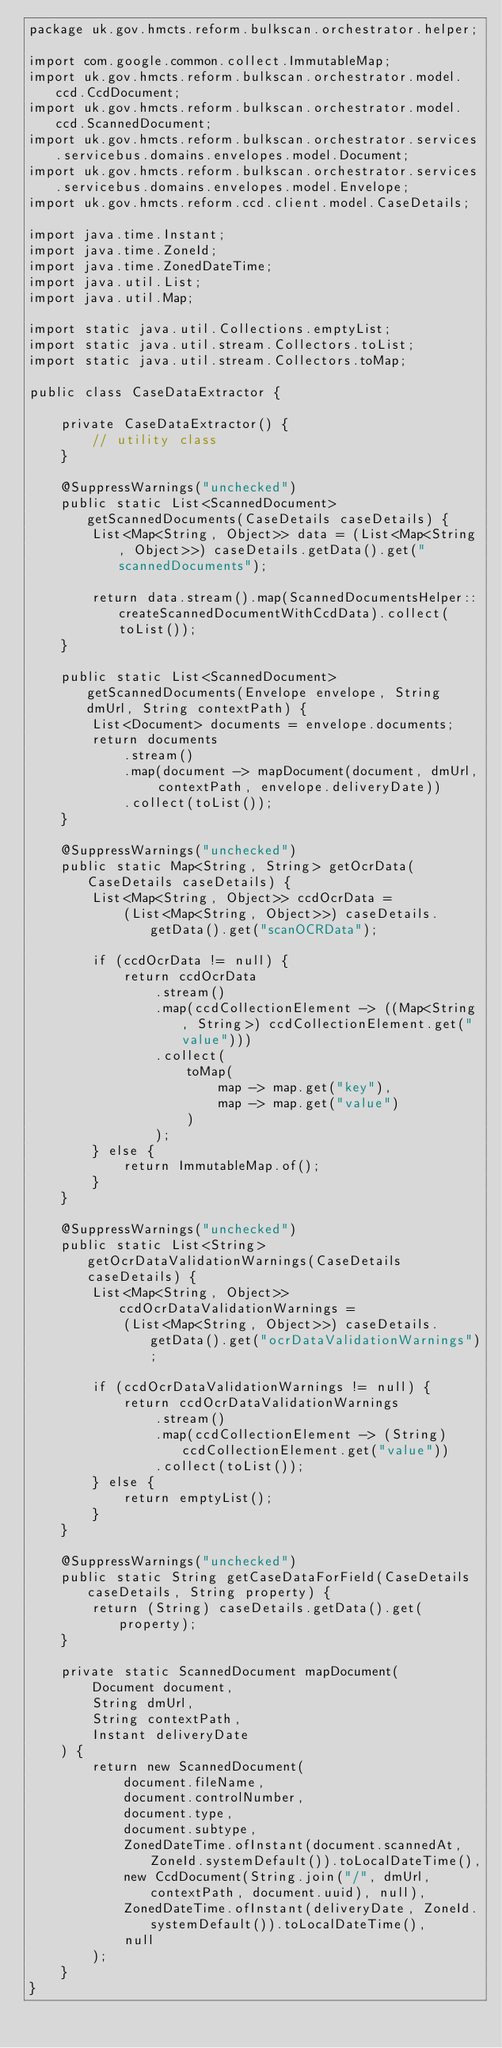<code> <loc_0><loc_0><loc_500><loc_500><_Java_>package uk.gov.hmcts.reform.bulkscan.orchestrator.helper;

import com.google.common.collect.ImmutableMap;
import uk.gov.hmcts.reform.bulkscan.orchestrator.model.ccd.CcdDocument;
import uk.gov.hmcts.reform.bulkscan.orchestrator.model.ccd.ScannedDocument;
import uk.gov.hmcts.reform.bulkscan.orchestrator.services.servicebus.domains.envelopes.model.Document;
import uk.gov.hmcts.reform.bulkscan.orchestrator.services.servicebus.domains.envelopes.model.Envelope;
import uk.gov.hmcts.reform.ccd.client.model.CaseDetails;

import java.time.Instant;
import java.time.ZoneId;
import java.time.ZonedDateTime;
import java.util.List;
import java.util.Map;

import static java.util.Collections.emptyList;
import static java.util.stream.Collectors.toList;
import static java.util.stream.Collectors.toMap;

public class CaseDataExtractor {

    private CaseDataExtractor() {
        // utility class
    }

    @SuppressWarnings("unchecked")
    public static List<ScannedDocument> getScannedDocuments(CaseDetails caseDetails) {
        List<Map<String, Object>> data = (List<Map<String, Object>>) caseDetails.getData().get("scannedDocuments");

        return data.stream().map(ScannedDocumentsHelper::createScannedDocumentWithCcdData).collect(toList());
    }

    public static List<ScannedDocument> getScannedDocuments(Envelope envelope, String dmUrl, String contextPath) {
        List<Document> documents = envelope.documents;
        return documents
            .stream()
            .map(document -> mapDocument(document, dmUrl, contextPath, envelope.deliveryDate))
            .collect(toList());
    }

    @SuppressWarnings("unchecked")
    public static Map<String, String> getOcrData(CaseDetails caseDetails) {
        List<Map<String, Object>> ccdOcrData =
            (List<Map<String, Object>>) caseDetails.getData().get("scanOCRData");

        if (ccdOcrData != null) {
            return ccdOcrData
                .stream()
                .map(ccdCollectionElement -> ((Map<String, String>) ccdCollectionElement.get("value")))
                .collect(
                    toMap(
                        map -> map.get("key"),
                        map -> map.get("value")
                    )
                );
        } else {
            return ImmutableMap.of();
        }
    }

    @SuppressWarnings("unchecked")
    public static List<String> getOcrDataValidationWarnings(CaseDetails caseDetails) {
        List<Map<String, Object>> ccdOcrDataValidationWarnings =
            (List<Map<String, Object>>) caseDetails.getData().get("ocrDataValidationWarnings");

        if (ccdOcrDataValidationWarnings != null) {
            return ccdOcrDataValidationWarnings
                .stream()
                .map(ccdCollectionElement -> (String)ccdCollectionElement.get("value"))
                .collect(toList());
        } else {
            return emptyList();
        }
    }

    @SuppressWarnings("unchecked")
    public static String getCaseDataForField(CaseDetails caseDetails, String property) {
        return (String) caseDetails.getData().get(property);
    }

    private static ScannedDocument mapDocument(
        Document document,
        String dmUrl,
        String contextPath,
        Instant deliveryDate
    ) {
        return new ScannedDocument(
            document.fileName,
            document.controlNumber,
            document.type,
            document.subtype,
            ZonedDateTime.ofInstant(document.scannedAt, ZoneId.systemDefault()).toLocalDateTime(),
            new CcdDocument(String.join("/", dmUrl, contextPath, document.uuid), null),
            ZonedDateTime.ofInstant(deliveryDate, ZoneId.systemDefault()).toLocalDateTime(),
            null
        );
    }
}
</code> 